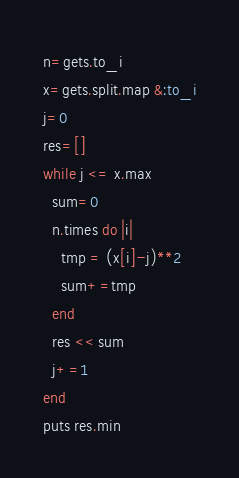<code> <loc_0><loc_0><loc_500><loc_500><_Ruby_>n=gets.to_i
x=gets.split.map &:to_i
j=0
res=[]
while j <= x.max
  sum=0
  n.times do |i|
    tmp = (x[i]-j)**2
    sum+=tmp
  end
  res << sum
  j+=1
end
puts res.min</code> 